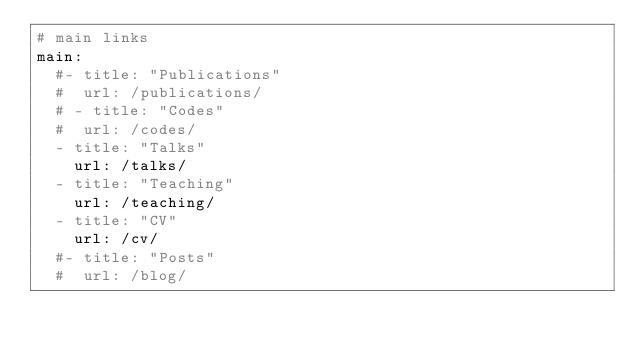<code> <loc_0><loc_0><loc_500><loc_500><_YAML_># main links
main:
  #- title: "Publications"
  #  url: /publications/
  # - title: "Codes"
  #  url: /codes/
  - title: "Talks"
    url: /talks/
  - title: "Teaching"
    url: /teaching/
  - title: "CV"
    url: /cv/
  #- title: "Posts"
  #  url: /blog/
</code> 